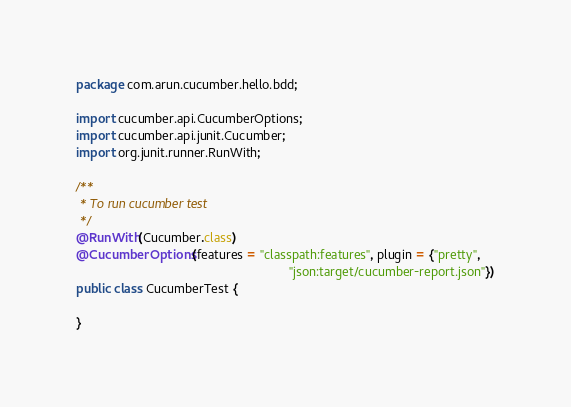<code> <loc_0><loc_0><loc_500><loc_500><_Java_>package com.arun.cucumber.hello.bdd;

import cucumber.api.CucumberOptions;
import cucumber.api.junit.Cucumber;
import org.junit.runner.RunWith;

/**
 * To run cucumber test
 */
@RunWith(Cucumber.class)
@CucumberOptions(features = "classpath:features", plugin = {"pretty",
                                                            "json:target/cucumber-report.json"})
public class CucumberTest {

}
</code> 